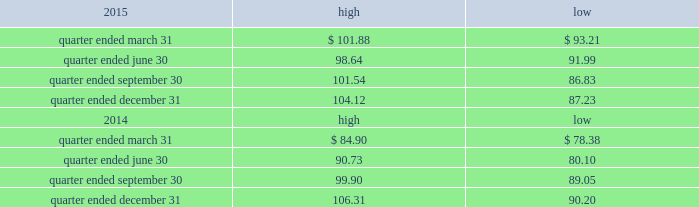Part ii item 5 .
Market for registrant 2019s common equity , related stockholder matters and issuer purchases of equity securities the table presents reported quarterly high and low per share sale prices of our common stock on the nyse for the years 2015 and 2014. .
On february 19 , 2016 , the closing price of our common stock was $ 87.32 per share as reported on the nyse .
As of february 19 , 2016 , we had 423897556 outstanding shares of common stock and 159 registered holders .
Dividends as a reit , we must annually distribute to our stockholders an amount equal to at least 90% ( 90 % ) of our reit taxable income ( determined before the deduction for distributed earnings and excluding any net capital gain ) .
Generally , we have distributed and expect to continue to distribute all or substantially all of our reit taxable income after taking into consideration our utilization of net operating losses ( 201cnols 201d ) .
We have two series of preferred stock outstanding , 5.25% ( 5.25 % ) mandatory convertible preferred stock , series a , issued in may 2014 ( the 201cseries a preferred stock 201d ) , with a dividend rate of 5.25% ( 5.25 % ) , and the 5.50% ( 5.50 % ) mandatory convertible preferred stock , series b ( the 201cseries b preferred stock 201d ) , issued in march 2015 , with a dividend rate of 5.50% ( 5.50 % ) .
Dividends are payable quarterly in arrears , subject to declaration by our board of directors .
The amount , timing and frequency of future distributions will be at the sole discretion of our board of directors and will be dependent upon various factors , a number of which may be beyond our control , including our financial condition and operating cash flows , the amount required to maintain our qualification for taxation as a reit and reduce any income and excise taxes that we otherwise would be required to pay , limitations on distributions in our existing and future debt and preferred equity instruments , our ability to utilize nols to offset our distribution requirements , limitations on our ability to fund distributions using cash generated through our trss and other factors that our board of directors may deem relevant .
We have distributed an aggregate of approximately $ 2.3 billion to our common stockholders , including the dividend paid in january 2016 , primarily subject to taxation as ordinary income .
During the year ended december 31 , 2015 , we declared the following cash distributions: .
What is the growth rate in the price of shares from the highest value during the quarter ended december 31 , 2015 and the closing price on february 19 , 2016? 
Computations: ((87.32 - 104.12) / 104.12)
Answer: -0.16135. 